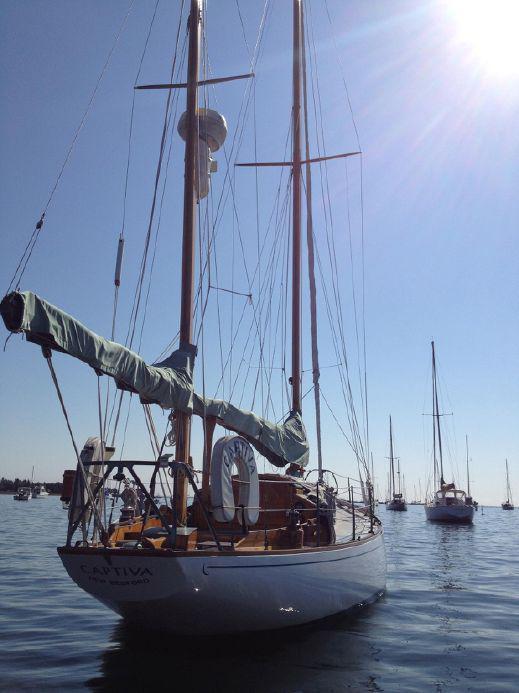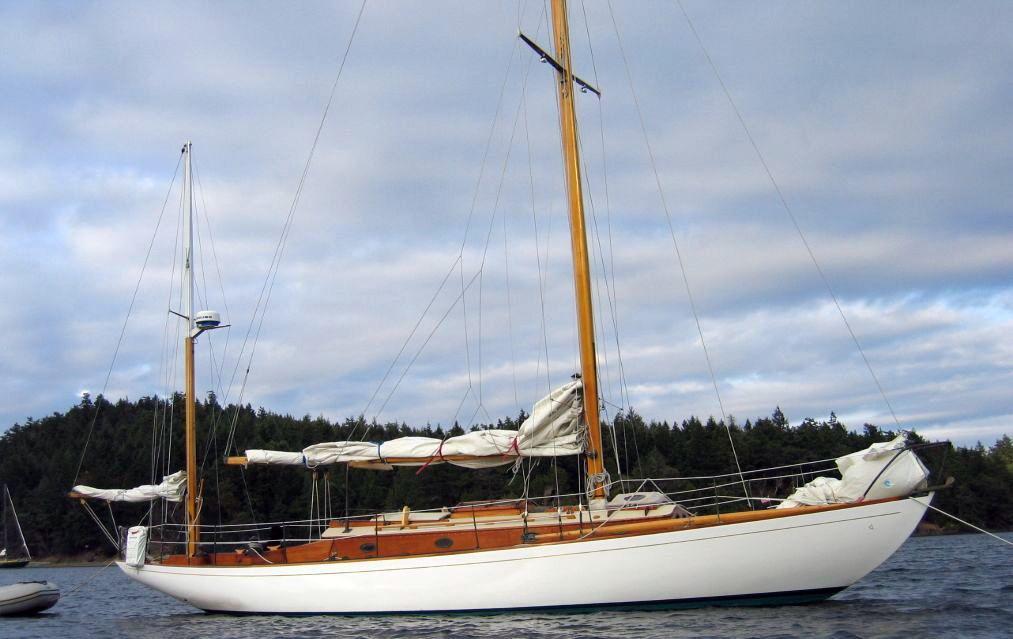The first image is the image on the left, the second image is the image on the right. Examine the images to the left and right. Is the description "On the right side of an image, a floating buoy extends from a boat into the water by a rope." accurate? Answer yes or no. No. The first image is the image on the left, the second image is the image on the right. Given the left and right images, does the statement "The sailboat in the image on the right has a black body." hold true? Answer yes or no. No. 